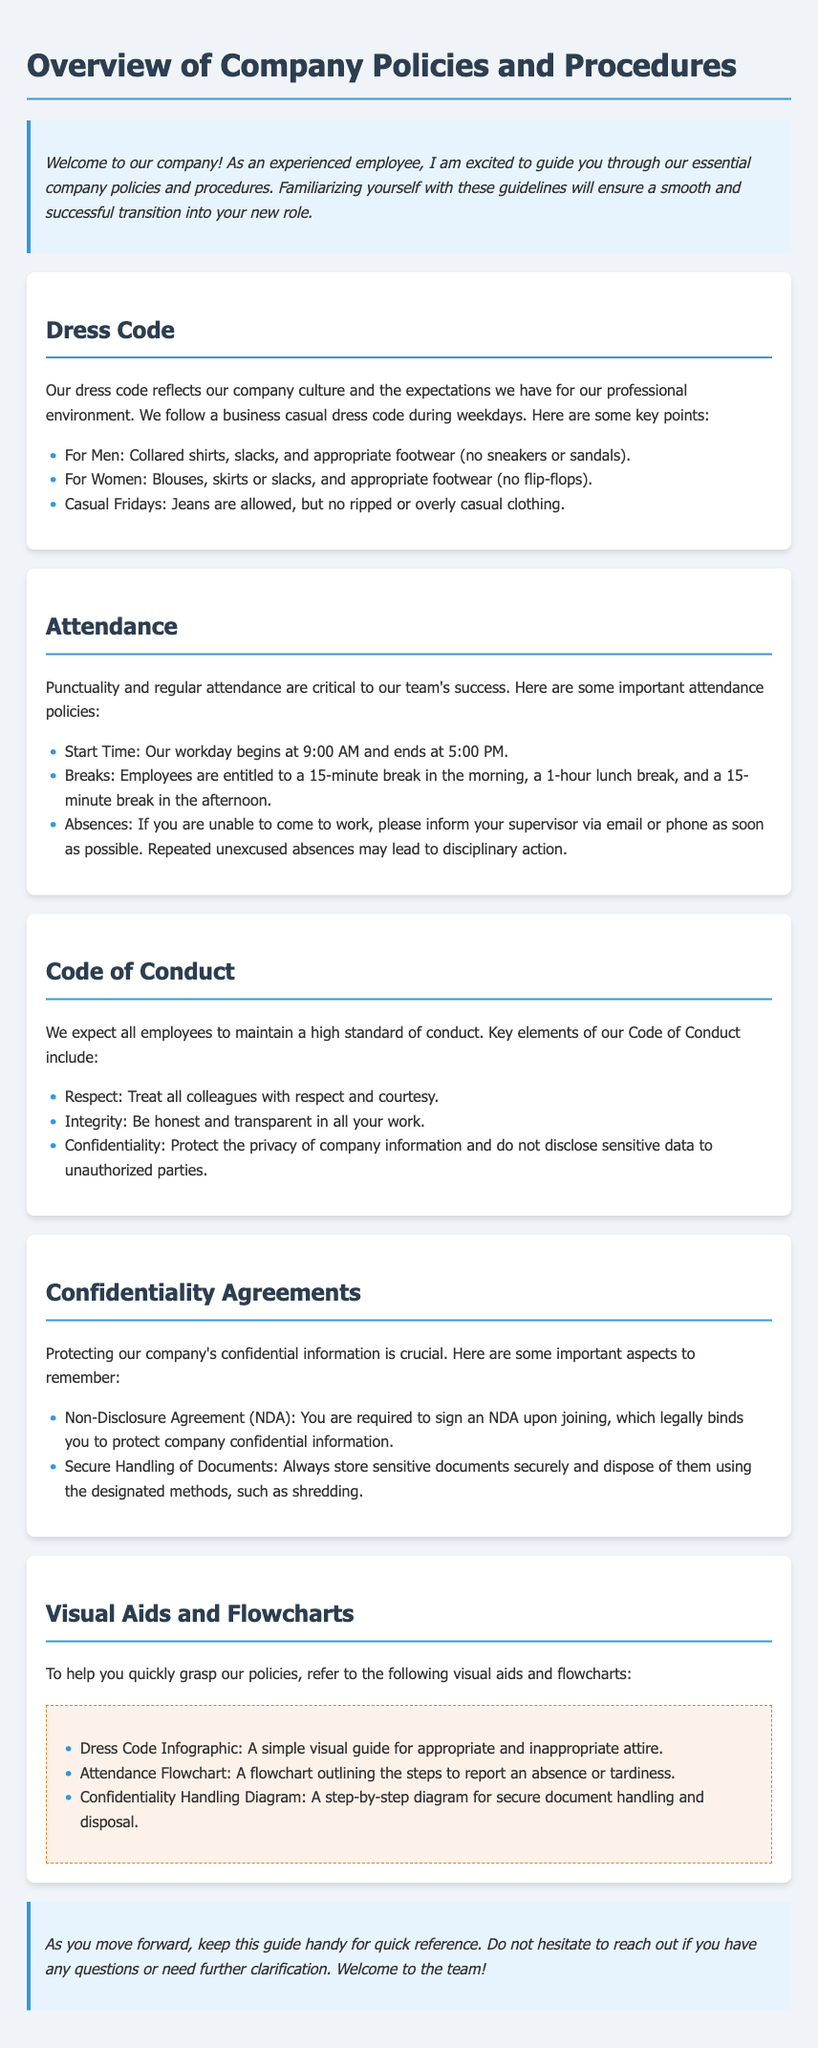What is the dress code during weekdays? The document states that the dress code during weekdays is business casual.
Answer: business casual What are the start and end times of the workday? The workday begins at 9:00 AM and ends at 5:00 PM.
Answer: 9:00 AM and 5:00 PM How many breaks are employees entitled to? The document specifies that employees are entitled to a total of three breaks throughout the day.
Answer: three breaks What must employees sign upon joining related to confidentiality? Employees are required to sign a Non-Disclosure Agreement upon joining.
Answer: Non-Disclosure Agreement What is an example of inappropriate attire mentioned? The document mentions that flip-flops are an example of inappropriate footwear for women.
Answer: flip-flops What action may be taken if there are repeated unexcused absences? The document notes that repeated unexcused absences may lead to disciplinary action.
Answer: disciplinary action What should you do if you cannot come to work? You should inform your supervisor via email or phone as soon as possible.
Answer: inform your supervisor What type of visual aid provides guidance on attire? The document references a Dress Code Infographic as a visual aid for appropriate attire.
Answer: Dress Code Infographic What is a key requirement of the Code of Conduct? A key requirement is to treat all colleagues with respect and courtesy.
Answer: respect 